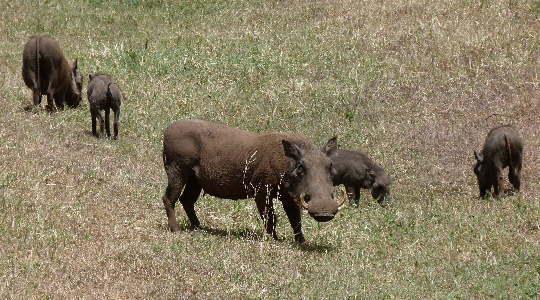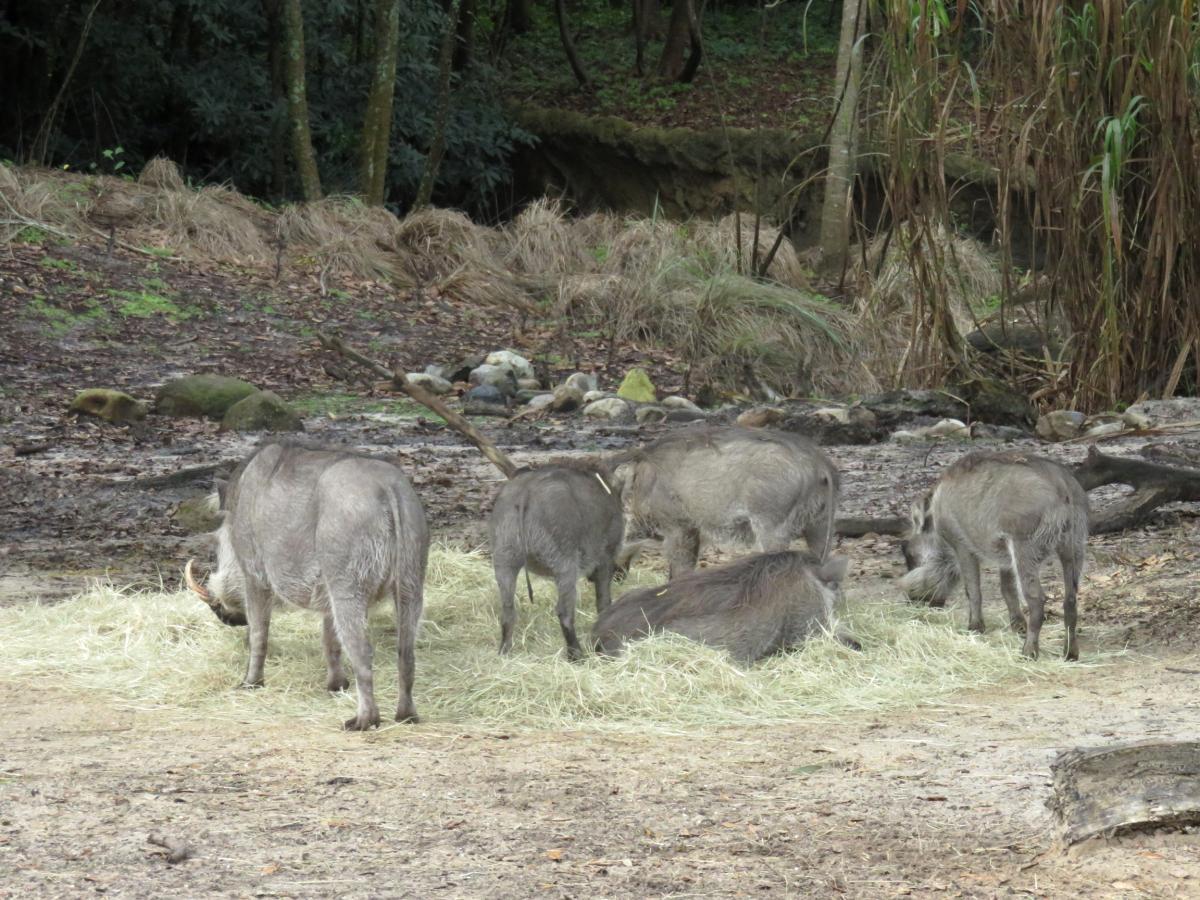The first image is the image on the left, the second image is the image on the right. Examine the images to the left and right. Is the description "The animals in one of the images are near a wet area." accurate? Answer yes or no. No. 